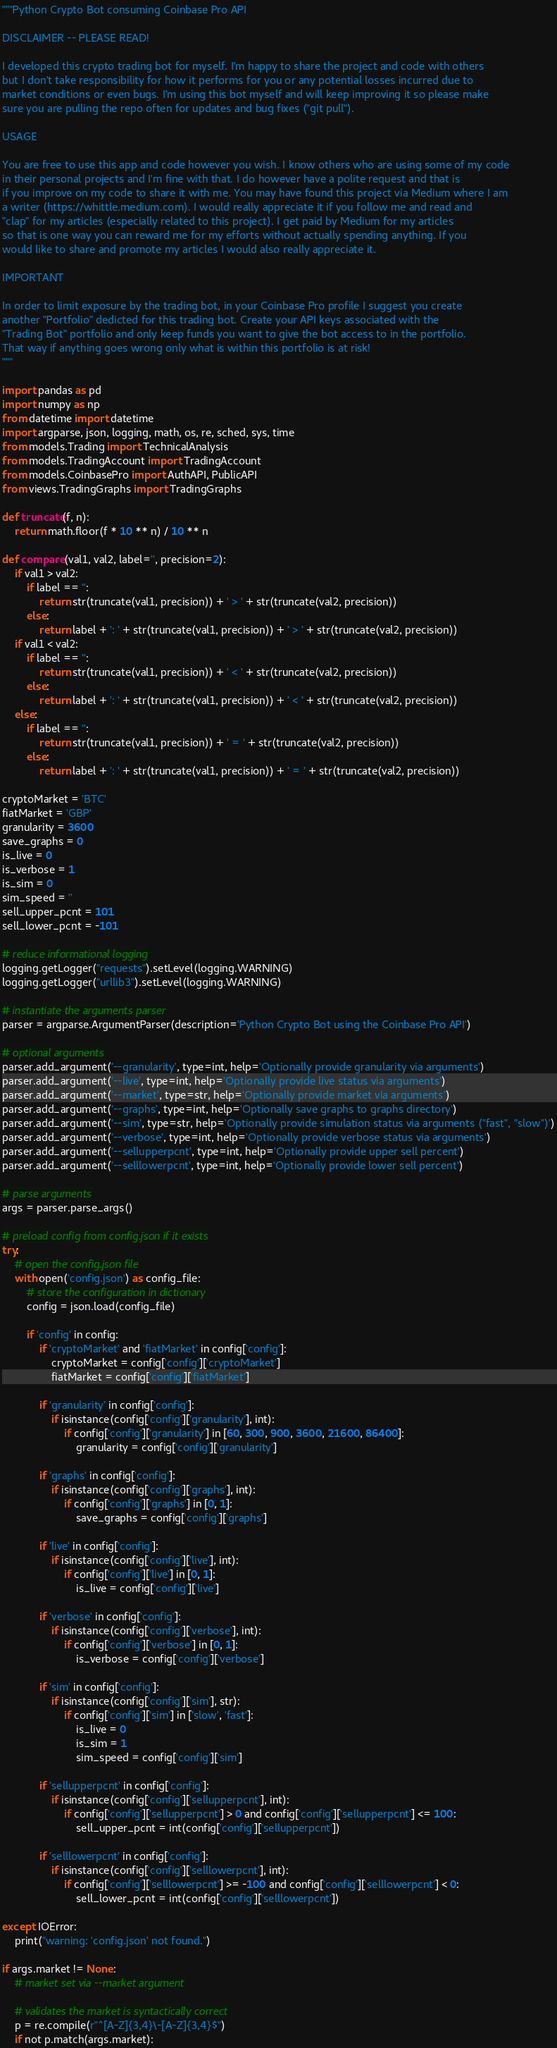Convert code to text. <code><loc_0><loc_0><loc_500><loc_500><_Python_>"""Python Crypto Bot consuming Coinbase Pro API

DISCLAIMER -- PLEASE READ!

I developed this crypto trading bot for myself. I'm happy to share the project and code with others
but I don't take responsibility for how it performs for you or any potential losses incurred due to
market conditions or even bugs. I'm using this bot myself and will keep improving it so please make
sure you are pulling the repo often for updates and bug fixes ("git pull"). 

USAGE

You are free to use this app and code however you wish. I know others who are using some of my code
in their personal projects and I'm fine with that. I do however have a polite request and that is
if you improve on my code to share it with me. You may have found this project via Medium where I am
a writer (https://whittle.medium.com). I would really appreciate it if you follow me and read and 
"clap" for my articles (especially related to this project). I get paid by Medium for my articles
so that is one way you can reward me for my efforts without actually spending anything. If you 
would like to share and promote my articles I would also really appreciate it.

IMPORTANT

In order to limit exposure by the trading bot, in your Coinbase Pro profile I suggest you create
another "Portfolio" dedicted for this trading bot. Create your API keys associated with the
"Trading Bot" portfolio and only keep funds you want to give the bot access to in the portfolio.
That way if anything goes wrong only what is within this portfolio is at risk!
"""

import pandas as pd
import numpy as np
from datetime import datetime
import argparse, json, logging, math, os, re, sched, sys, time
from models.Trading import TechnicalAnalysis
from models.TradingAccount import TradingAccount
from models.CoinbasePro import AuthAPI, PublicAPI
from views.TradingGraphs import TradingGraphs

def truncate(f, n):
    return math.floor(f * 10 ** n) / 10 ** n

def compare(val1, val2, label='', precision=2):
    if val1 > val2:
        if label == '':
            return str(truncate(val1, precision)) + ' > ' + str(truncate(val2, precision))
        else:
            return label + ': ' + str(truncate(val1, precision)) + ' > ' + str(truncate(val2, precision))
    if val1 < val2:
        if label == '':
            return str(truncate(val1, precision)) + ' < ' + str(truncate(val2, precision))
        else:
            return label + ': ' + str(truncate(val1, precision)) + ' < ' + str(truncate(val2, precision))
    else:
        if label == '':
            return str(truncate(val1, precision)) + ' = ' + str(truncate(val2, precision))
        else:
            return label + ': ' + str(truncate(val1, precision)) + ' = ' + str(truncate(val2, precision))      

cryptoMarket = 'BTC'
fiatMarket = 'GBP'
granularity = 3600
save_graphs = 0
is_live = 0
is_verbose = 1
is_sim = 0
sim_speed = ''
sell_upper_pcnt = 101
sell_lower_pcnt = -101

# reduce informational logging
logging.getLogger("requests").setLevel(logging.WARNING)
logging.getLogger("urllib3").setLevel(logging.WARNING)

# instantiate the arguments parser
parser = argparse.ArgumentParser(description='Python Crypto Bot using the Coinbase Pro API')

# optional arguments
parser.add_argument('--granularity', type=int, help='Optionally provide granularity via arguments')
parser.add_argument('--live', type=int, help='Optionally provide live status via arguments')
parser.add_argument('--market', type=str, help='Optionally provide market via arguments')
parser.add_argument('--graphs', type=int, help='Optionally save graphs to graphs directory')
parser.add_argument('--sim', type=str, help='Optionally provide simulation status via arguments ("fast", "slow")')
parser.add_argument('--verbose', type=int, help='Optionally provide verbose status via arguments')
parser.add_argument('--sellupperpcnt', type=int, help='Optionally provide upper sell percent')
parser.add_argument('--selllowerpcnt', type=int, help='Optionally provide lower sell percent')

# parse arguments
args = parser.parse_args()

# preload config from config.json if it exists
try:
    # open the config.json file
    with open('config.json') as config_file:
        # store the configuration in dictionary
        config = json.load(config_file)

        if 'config' in config:
            if 'cryptoMarket' and 'fiatMarket' in config['config']:
                cryptoMarket = config['config']['cryptoMarket']
                fiatMarket = config['config']['fiatMarket']

            if 'granularity' in config['config']:
                if isinstance(config['config']['granularity'], int):
                    if config['config']['granularity'] in [60, 300, 900, 3600, 21600, 86400]:
                        granularity = config['config']['granularity']

            if 'graphs' in config['config']:
                if isinstance(config['config']['graphs'], int):
                    if config['config']['graphs'] in [0, 1]:
                        save_graphs = config['config']['graphs']

            if 'live' in config['config']:
                if isinstance(config['config']['live'], int):
                    if config['config']['live'] in [0, 1]:
                        is_live = config['config']['live']

            if 'verbose' in config['config']:
                if isinstance(config['config']['verbose'], int):
                    if config['config']['verbose'] in [0, 1]:
                        is_verbose = config['config']['verbose']

            if 'sim' in config['config']:
                if isinstance(config['config']['sim'], str):
                    if config['config']['sim'] in ['slow', 'fast']:
                        is_live = 0
                        is_sim = 1
                        sim_speed = config['config']['sim']

            if 'sellupperpcnt' in config['config']:
                if isinstance(config['config']['sellupperpcnt'], int):
                    if config['config']['sellupperpcnt'] > 0 and config['config']['sellupperpcnt'] <= 100:
                        sell_upper_pcnt = int(config['config']['sellupperpcnt'])

            if 'selllowerpcnt' in config['config']:
                if isinstance(config['config']['selllowerpcnt'], int):
                    if config['config']['selllowerpcnt'] >= -100 and config['config']['selllowerpcnt'] < 0:
                        sell_lower_pcnt = int(config['config']['selllowerpcnt'])

except IOError:
    print("warning: 'config.json' not found.")

if args.market != None:
    # market set via --market argument

    # validates the market is syntactically correct
    p = re.compile(r"^[A-Z]{3,4}\-[A-Z]{3,4}$")
    if not p.match(args.market):</code> 